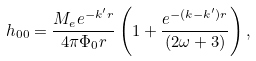<formula> <loc_0><loc_0><loc_500><loc_500>h _ { 0 0 } = \frac { M _ { e } e ^ { - k ^ { \prime } r } } { 4 \pi \Phi _ { 0 } r } \left ( 1 + \frac { e ^ { - ( k - k ^ { \prime } ) r } } { ( 2 \omega + 3 ) } \right ) ,</formula> 